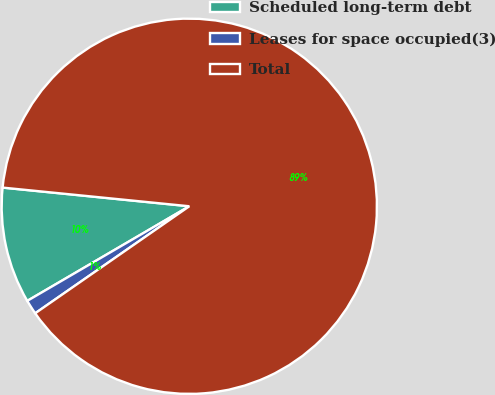<chart> <loc_0><loc_0><loc_500><loc_500><pie_chart><fcel>Scheduled long-term debt<fcel>Leases for space occupied(3)<fcel>Total<nl><fcel>10.0%<fcel>1.25%<fcel>88.76%<nl></chart> 